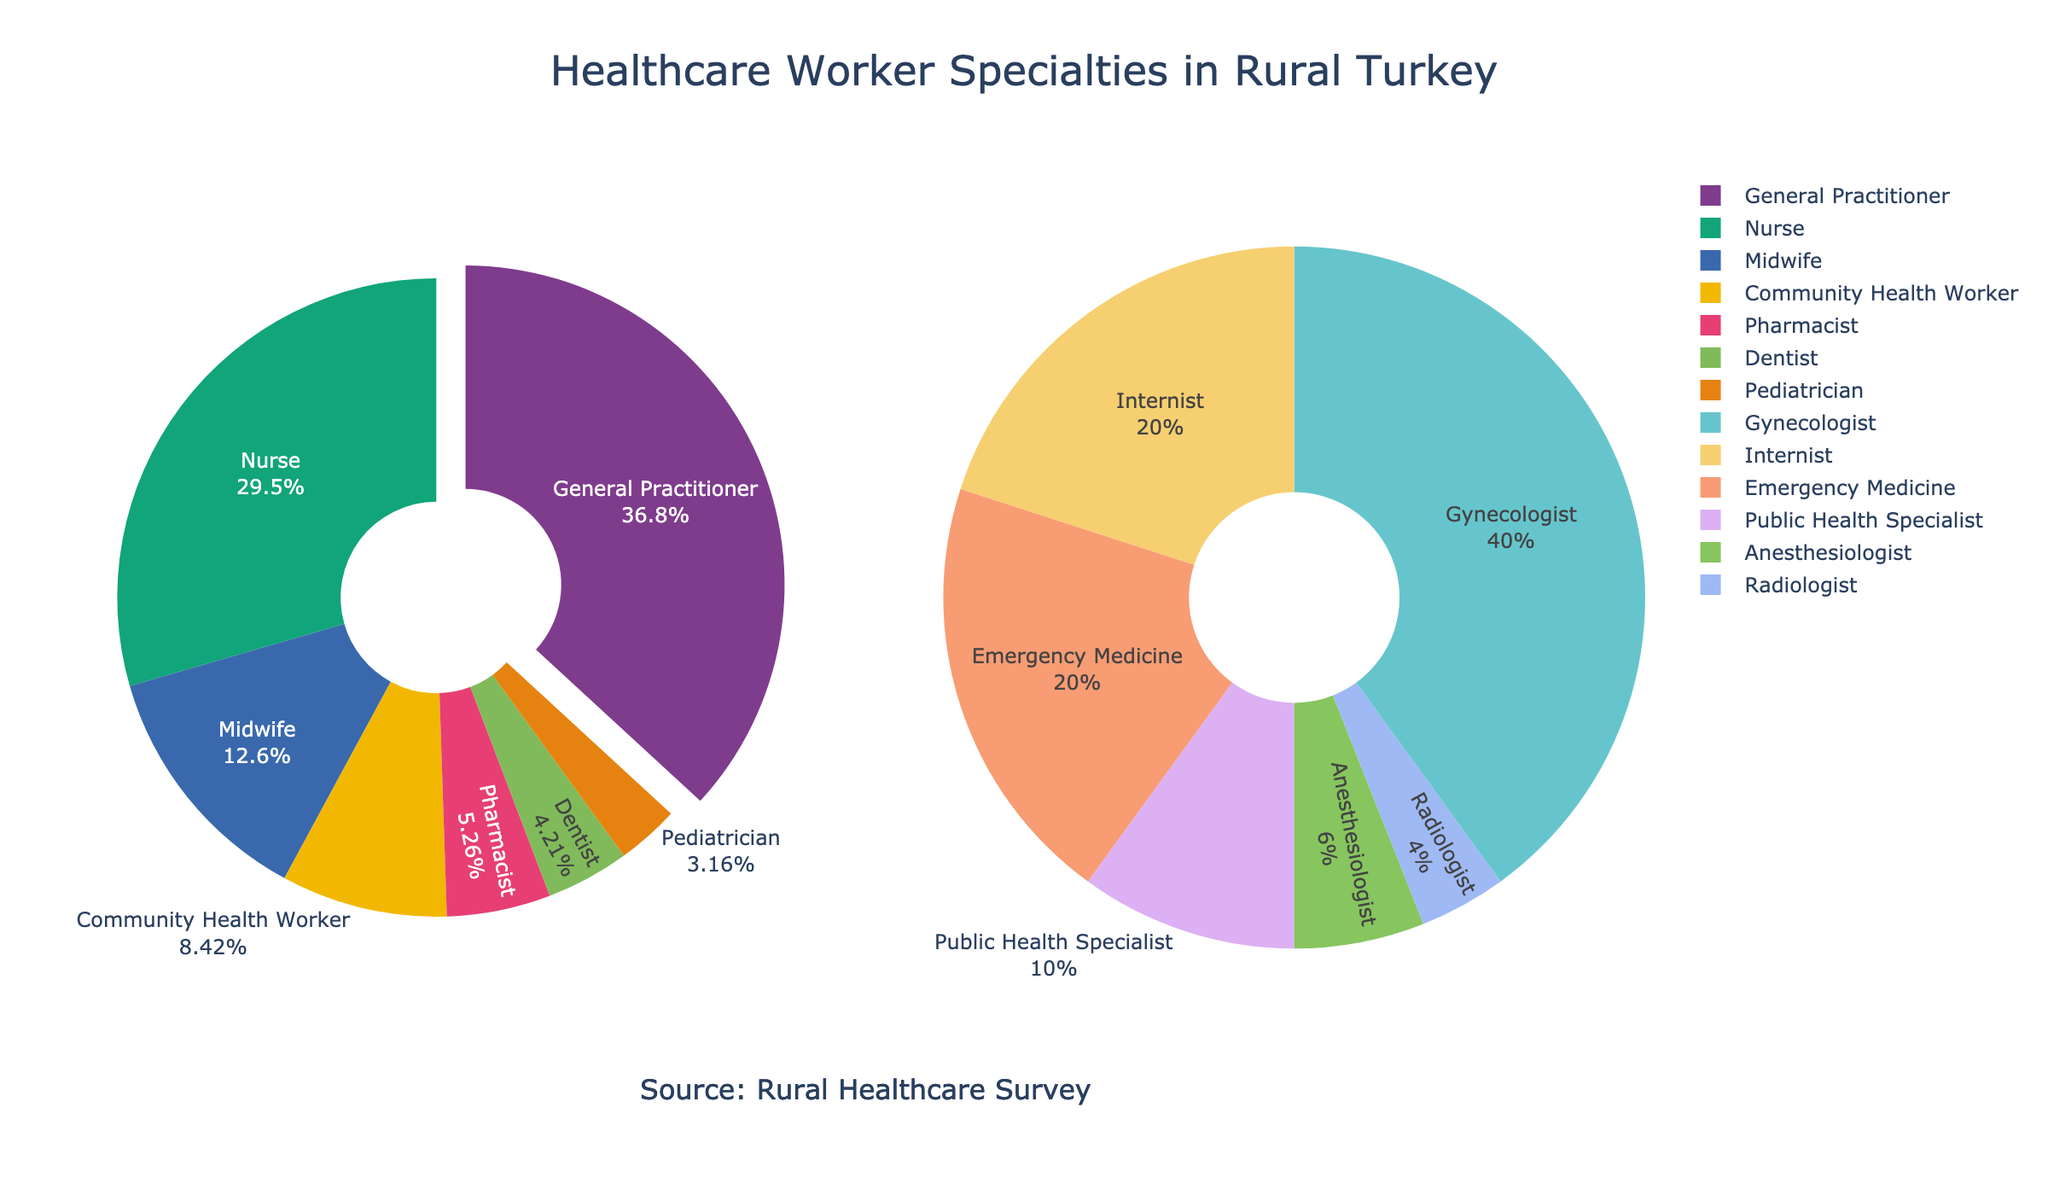What percentage of healthcare workers are General Practitioners? Look at the figure and find the percentage slice labeled as "General Practitioner" to see it comprises 35% of the total
Answer: 35% Which specialty has the smallest representation among healthcare workers, and what is its percentage? In the "Other Specialties" pie chart, identify the smallest slice labeled as "Radiologist" with a percentage of 0.2%
Answer: Radiologist, 0.2% How much more prevalent are Nurses compared to Midwives? Refer to the figure and note that Nurses make up 28% while Midwives are 12%. Calculate the difference: 28% - 12% = 16%
Answer: 16% What specialties make up the "Other Specialties" pie chart, and what is their combined percentage? List down all the specialties in the "Other Specialties" part of the pie chart: Community Health Worker (8%), Pharmacist (5%), Dentist (4%), Pediatrician (3%), Gynecologist (2%), Internist (1%), Emergency Medicine (1%), Public Health Specialist (0.5%), Anesthesiologist (0.3%), Radiologist (0.2%). Add these percentages together: 8% + 5% + 4% + 3% + 2% + 1% + 1% + 0.5% + 0.3% + 0.2% = 25%
Answer: Community Health Worker, Pharmacist, Dentist, Pediatrician, Gynecologist, Internist, Emergency Medicine, Public Health Specialist, Anesthesiologist, Radiologist, 25% Which specialty is more common: Pediatrician or Gynecologist, and by how much? Compare the slices for Pediatrician (3%) and Gynecologist (2%). Calculate the difference: 3% - 2% = 1%
Answer: Pediatrician, 1% Are there more Midwives or Pharmacists, and by what percentage difference? Compare the sizes in the figure for Midwives (12%) and Pharmacists (5%). Calculate the difference: 12% - 5% = 7%
Answer: Midwives, 7% What percentage of healthcare workers are represented in the "Main Specialties" pie chart? Sum the percentages in the "Main Specialties" pie chart: General Practitioner (35%) + Nurse (28%) + Midwife (12%) = 75%
Answer: 75% Who represent the higher percentage: Dentists or Pharmacists? Look at the figure to find that Pharmacists are 5% and Dentists are 4%. Pharmacists are higher
Answer: Pharmacists What is the combined percentage of Internists and Public Health Specialists? Sum the percentages from the "Other Specialties" pie chart: Internist (1%) + Public Health Specialist (0.5%) = 1.5%
Answer: 1.5% How many specialties are included in the "Other Specialties" pie chart? Count the different labels in the "Other Specialties" pie chart: Community Health Worker, Pharmacist, Dentist, Pediatrician, Gynecologist, Internist, Emergency Medicine, Public Health Specialist, Anesthesiologist, Radiologist = 10
Answer: 10 